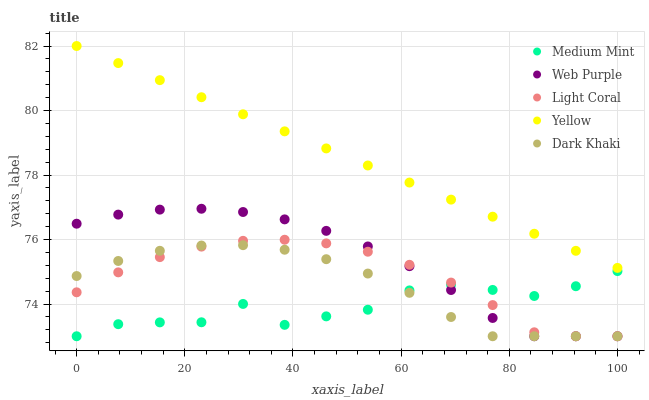Does Medium Mint have the minimum area under the curve?
Answer yes or no. Yes. Does Yellow have the maximum area under the curve?
Answer yes or no. Yes. Does Light Coral have the minimum area under the curve?
Answer yes or no. No. Does Light Coral have the maximum area under the curve?
Answer yes or no. No. Is Yellow the smoothest?
Answer yes or no. Yes. Is Medium Mint the roughest?
Answer yes or no. Yes. Is Light Coral the smoothest?
Answer yes or no. No. Is Light Coral the roughest?
Answer yes or no. No. Does Medium Mint have the lowest value?
Answer yes or no. Yes. Does Yellow have the lowest value?
Answer yes or no. No. Does Yellow have the highest value?
Answer yes or no. Yes. Does Light Coral have the highest value?
Answer yes or no. No. Is Light Coral less than Yellow?
Answer yes or no. Yes. Is Yellow greater than Light Coral?
Answer yes or no. Yes. Does Dark Khaki intersect Web Purple?
Answer yes or no. Yes. Is Dark Khaki less than Web Purple?
Answer yes or no. No. Is Dark Khaki greater than Web Purple?
Answer yes or no. No. Does Light Coral intersect Yellow?
Answer yes or no. No. 